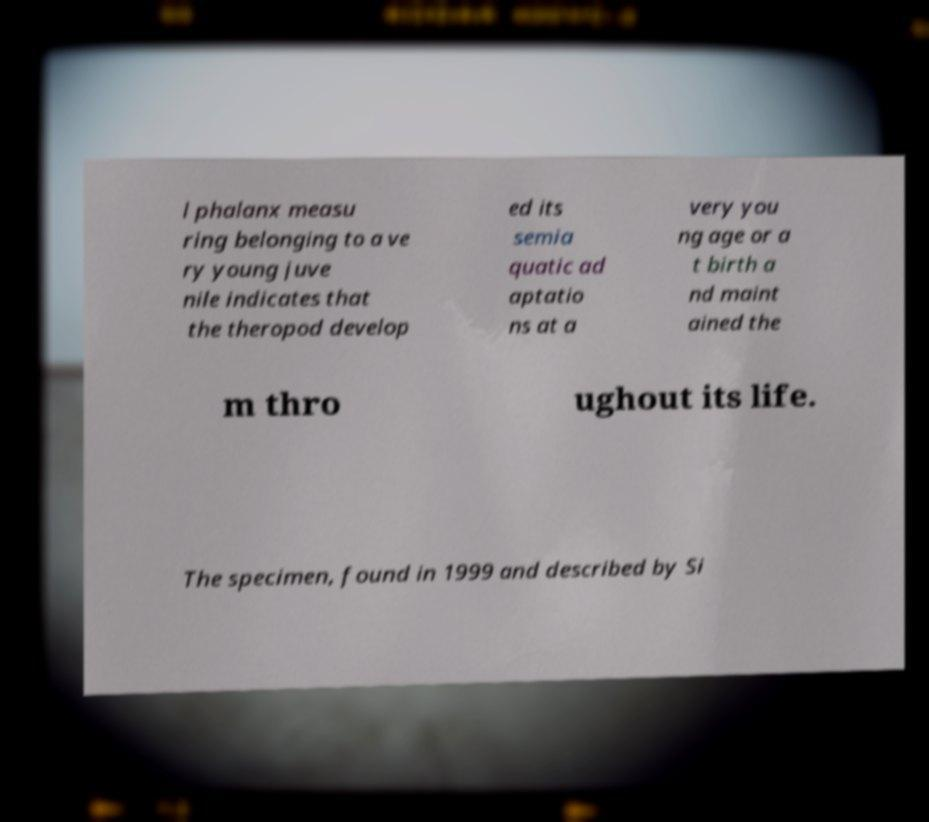Could you extract and type out the text from this image? l phalanx measu ring belonging to a ve ry young juve nile indicates that the theropod develop ed its semia quatic ad aptatio ns at a very you ng age or a t birth a nd maint ained the m thro ughout its life. The specimen, found in 1999 and described by Si 